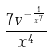Convert formula to latex. <formula><loc_0><loc_0><loc_500><loc_500>\frac { 7 v ^ { - \frac { 1 } { x ^ { 7 } } } } { x ^ { 4 } }</formula> 